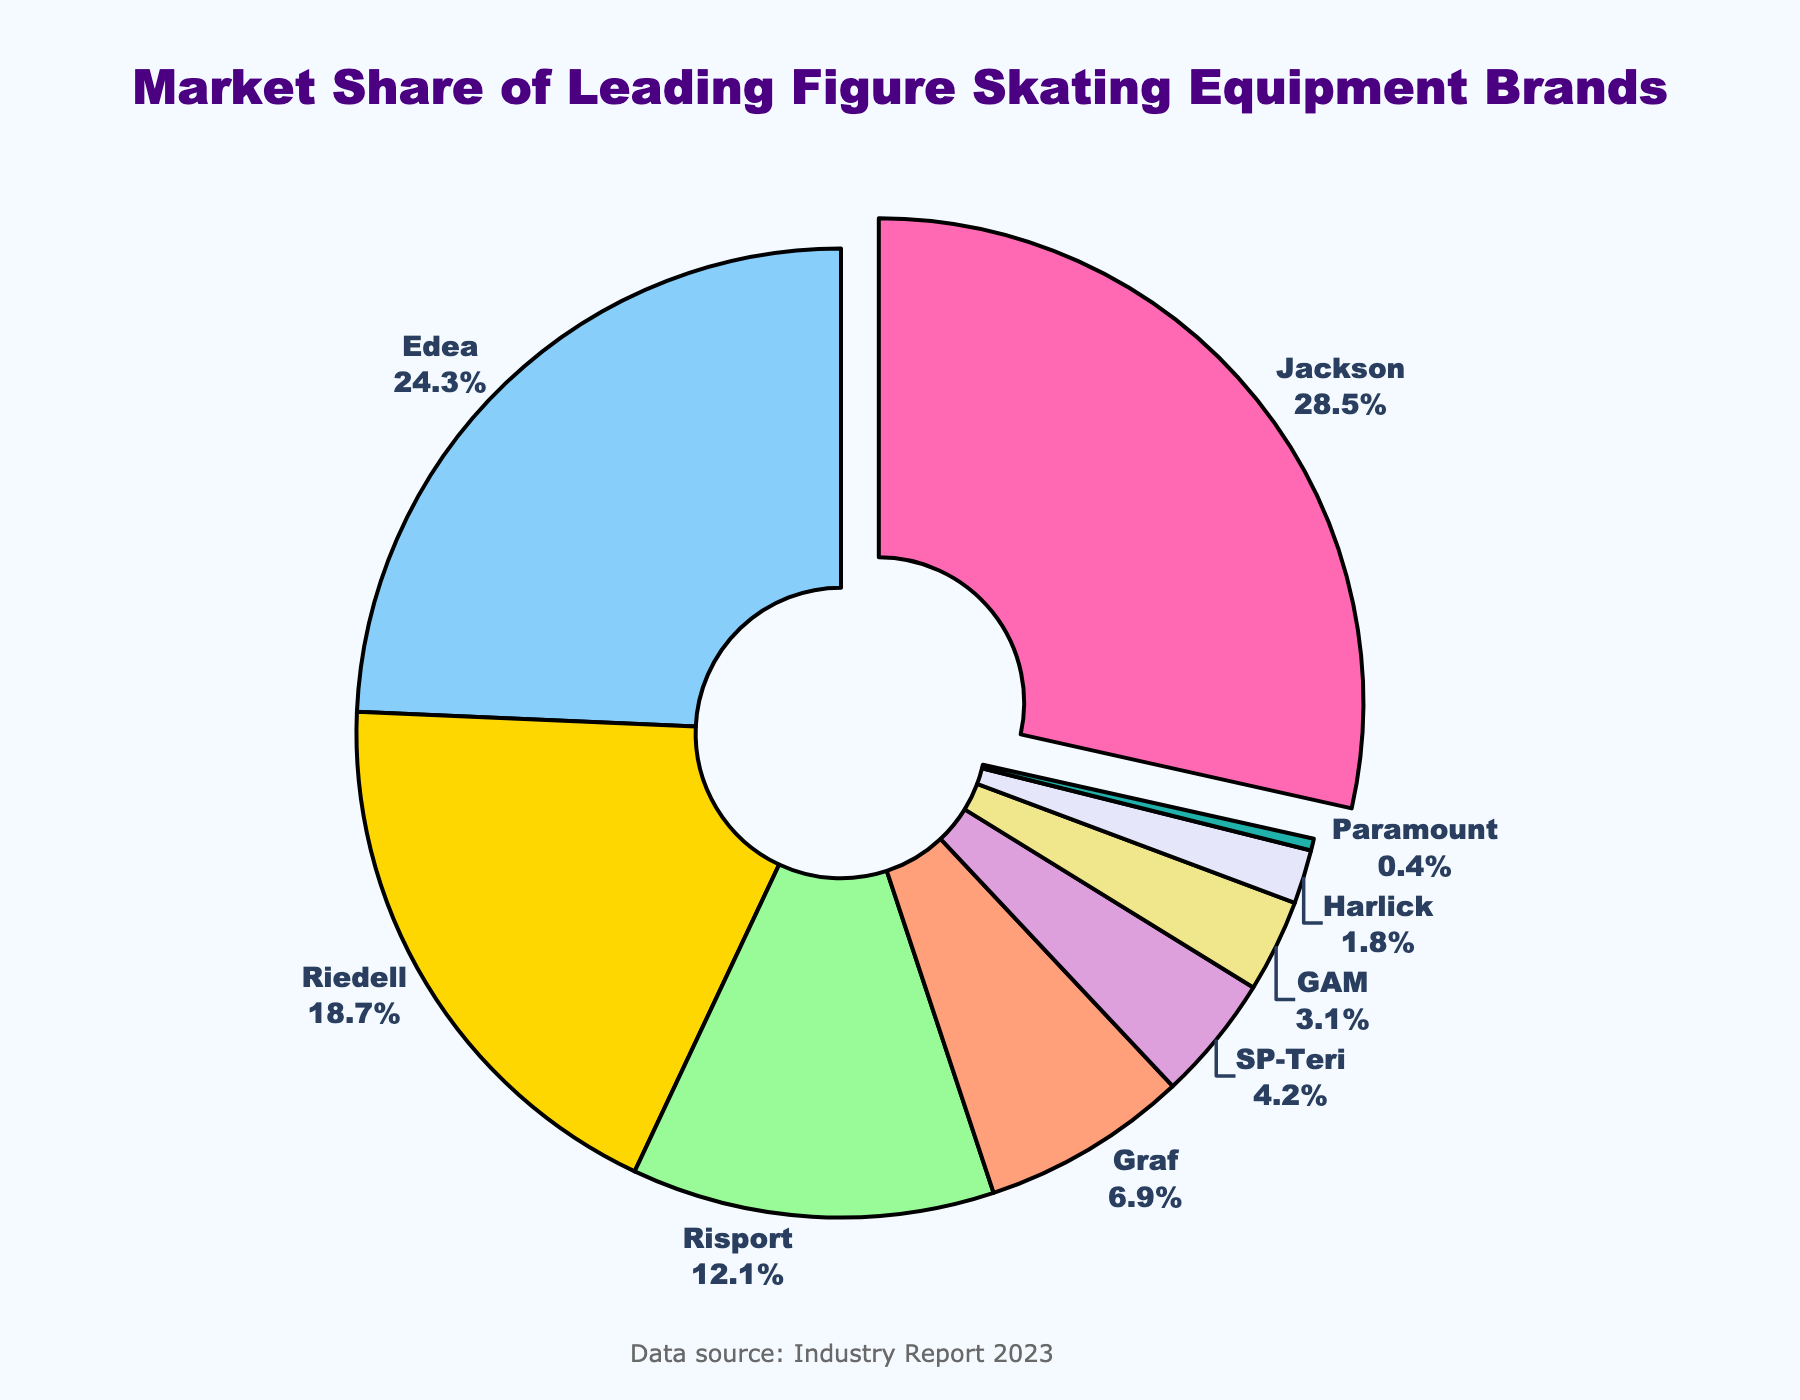Which brand has the largest market share? Jackson has the largest market share, which can be seen by the largest slice being slightly pulled out from the pie and showing 28.5%.
Answer: Jackson What is the combined market share of Edea and Riedell? Edea has 24.3% and Riedell has 18.7%. Adding these gives 24.3 + 18.7 = 43%.
Answer: 43% Which two brands together have a market share closest to 30%? Looking at the values, Risport has 12.1% and Graf has 6.9%, summing them gives 12.1 + 6.9 = 19%. Adding SP-Teri’s 4.2% to Graf’s 6.9% gives 6.9 + 4.2 = 11.1%. Adding GAM’s 3.1% to SP-Teri’s 4.2% gives 4.2 + 3.1 = 7.3%. The closest pair is likely SP-Teri (4.2) and GAM (3.1). Summing them gives 4.2 + 3.1 = 7.3% or Jackson (28.5) and Paramount (0.4) giving 28.9% which is closest.
Answer: Jackson and Paramount Which brand has a smaller market share, Harlick or SP-Teri? SP-Teri is labeled with 4.2% and Harlick with 1.8%, thus Harlick has a smaller market share.
Answer: Harlick How many brands have a market share of less than 5%? Observing the chart, brands with market shares less than 5% are Graf (6.9), SP-Teri (4.2), GAM (3.1), Harlick (1.8), and Paramount (0.4), so there are 4 brands.
Answer: 4 What is the difference in market share between Jackson and Risport? Jackson has 28.5% and Risport has 12.1%. The difference is calculated as 28.5 - 12.1 = 16.4%.
Answer: 16.4% What is the average market share of all the brands? Sum all market shares: 28.5 + 24.3 + 18.7 + 12.1 + 6.9 + 4.2 + 3.1 + 1.8 + 0.4 = 100%. There are 9 brands, so the average is 100 / 9 = 11.11%.
Answer: 11.11% Which brand has the second-largest market share? The second largest segment by size after Jackson (28.5%) is Edea with 24.3%.
Answer: Edea What is the total market share of brands with more than 20%? Only Jackson (28.5%) and Edea (24.3%) have more than 20%. Adding these gives 28.5 + 24.3 = 52.8%.
Answer: 52.8% What colors are used to represent Jackson and Graf? Jackson is represented by a hot pink color and Graf is represented by a salmon pink color.
Answer: Hot pink and salmon pink 